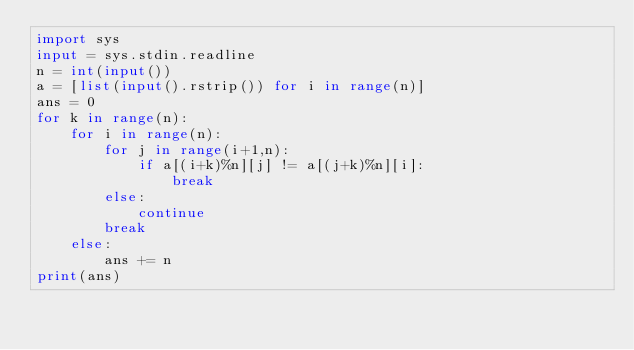<code> <loc_0><loc_0><loc_500><loc_500><_Python_>import sys
input = sys.stdin.readline
n = int(input())
a = [list(input().rstrip()) for i in range(n)]
ans = 0
for k in range(n):
    for i in range(n):
        for j in range(i+1,n):
            if a[(i+k)%n][j] != a[(j+k)%n][i]:
                break
        else:
            continue
        break
    else:
        ans += n
print(ans)</code> 